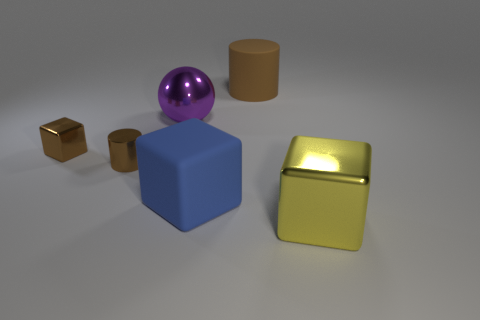There is a matte cylinder that is the same color as the tiny cube; what is its size?
Keep it short and to the point. Large. What is the material of the block that is the same color as the shiny cylinder?
Provide a short and direct response. Metal. Is the material of the brown cylinder behind the small brown metal cube the same as the purple object?
Provide a succinct answer. No. The other large object that is the same shape as the yellow thing is what color?
Ensure brevity in your answer.  Blue. What number of other objects are there of the same color as the rubber cylinder?
Provide a short and direct response. 2. Do the large rubber thing left of the big cylinder and the brown thing on the right side of the big purple sphere have the same shape?
Offer a terse response. No. How many cylinders are large yellow things or small brown objects?
Your response must be concise. 1. Is the number of yellow blocks that are behind the matte block less than the number of big blue rubber spheres?
Your response must be concise. No. How many other things are there of the same material as the small cylinder?
Offer a terse response. 3. Is the size of the metal cylinder the same as the blue object?
Provide a succinct answer. No. 